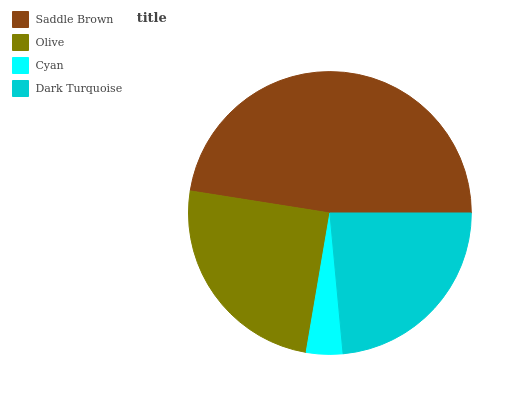Is Cyan the minimum?
Answer yes or no. Yes. Is Saddle Brown the maximum?
Answer yes or no. Yes. Is Olive the minimum?
Answer yes or no. No. Is Olive the maximum?
Answer yes or no. No. Is Saddle Brown greater than Olive?
Answer yes or no. Yes. Is Olive less than Saddle Brown?
Answer yes or no. Yes. Is Olive greater than Saddle Brown?
Answer yes or no. No. Is Saddle Brown less than Olive?
Answer yes or no. No. Is Olive the high median?
Answer yes or no. Yes. Is Dark Turquoise the low median?
Answer yes or no. Yes. Is Cyan the high median?
Answer yes or no. No. Is Olive the low median?
Answer yes or no. No. 